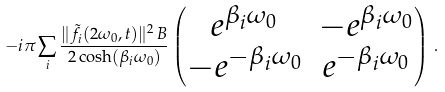<formula> <loc_0><loc_0><loc_500><loc_500>- i \pi \sum _ { i } \frac { \| \tilde { f } _ { i } ( 2 \omega _ { 0 } , t ) \| ^ { 2 } _ { \ } B } { 2 \cosh ( \beta _ { i } \omega _ { 0 } ) } \left ( \begin{matrix} e ^ { \beta _ { i } \omega _ { 0 } } & - e ^ { \beta _ { i } \omega _ { 0 } } \\ - e ^ { - \beta _ { i } \omega _ { 0 } } & e ^ { - \beta _ { i } \omega _ { 0 } } \end{matrix} \right ) \, .</formula> 